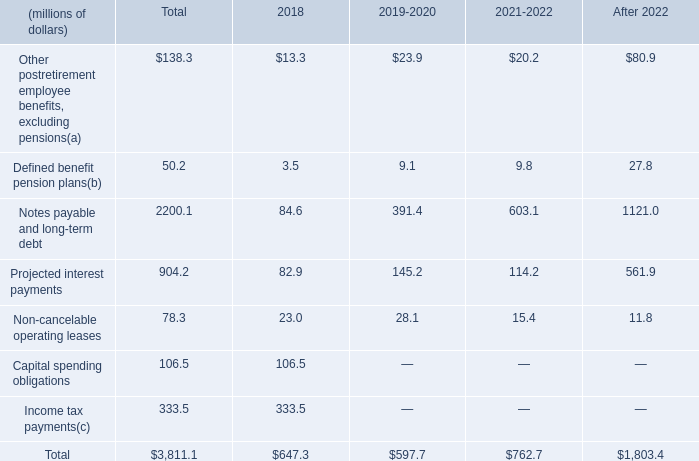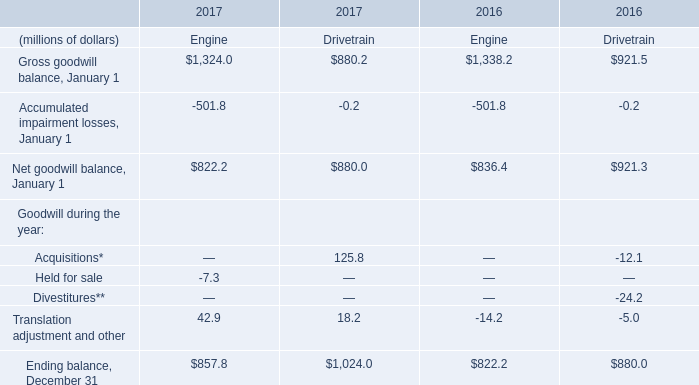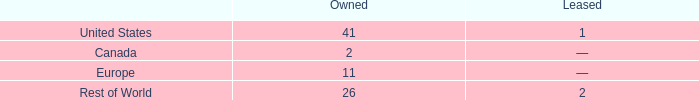what portion of the company owned facilities are located in united states? 
Computations: (41 / 80)
Answer: 0.5125. 